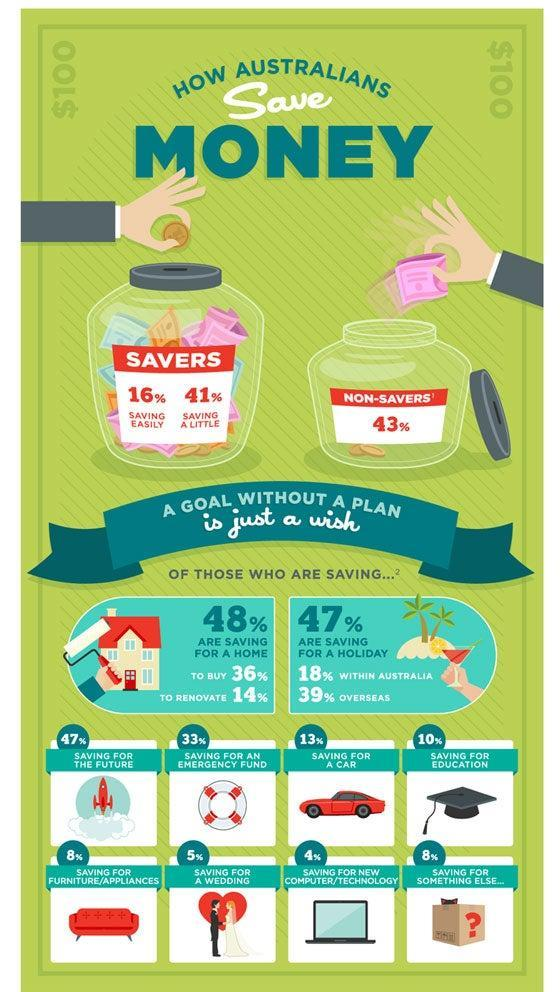What percent of australians are non-savers?
Answer the question with a short phrase. 43% Which activity is considered as least savings for australians? SAVINGS FOR NEW COMPUTER/TECHNOLOGY What percentage of Australians are saving money for furniture/appliances? 8% What percent of australians are saving money easily? 16% What percentage of Australians are saving money to buy a house? 36% What percentage of Australians are saving money for an emergency fund? 33% What does 10% savings of australians meant to be? Saving for Education 